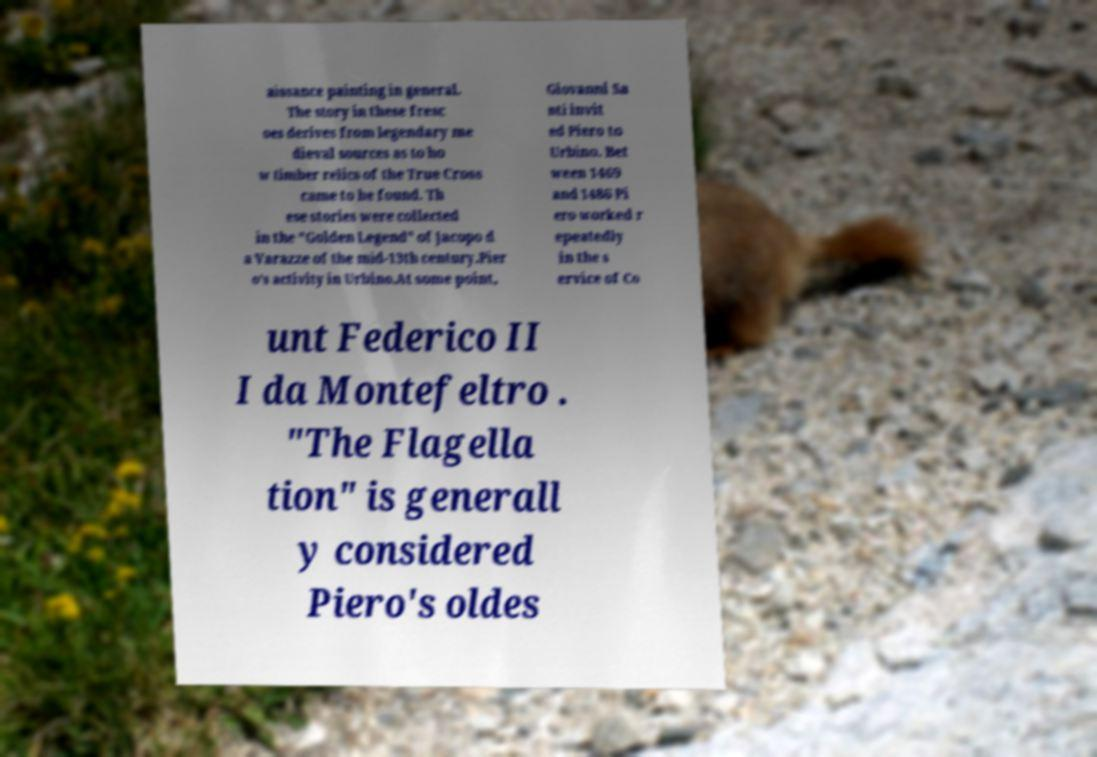Please read and relay the text visible in this image. What does it say? aissance painting in general. The story in these fresc oes derives from legendary me dieval sources as to ho w timber relics of the True Cross came to be found. Th ese stories were collected in the "Golden Legend" of Jacopo d a Varazze of the mid-13th century.Pier o's activity in Urbino.At some point, Giovanni Sa nti invit ed Piero to Urbino. Bet ween 1469 and 1486 Pi ero worked r epeatedly in the s ervice of Co unt Federico II I da Montefeltro . "The Flagella tion" is generall y considered Piero's oldes 